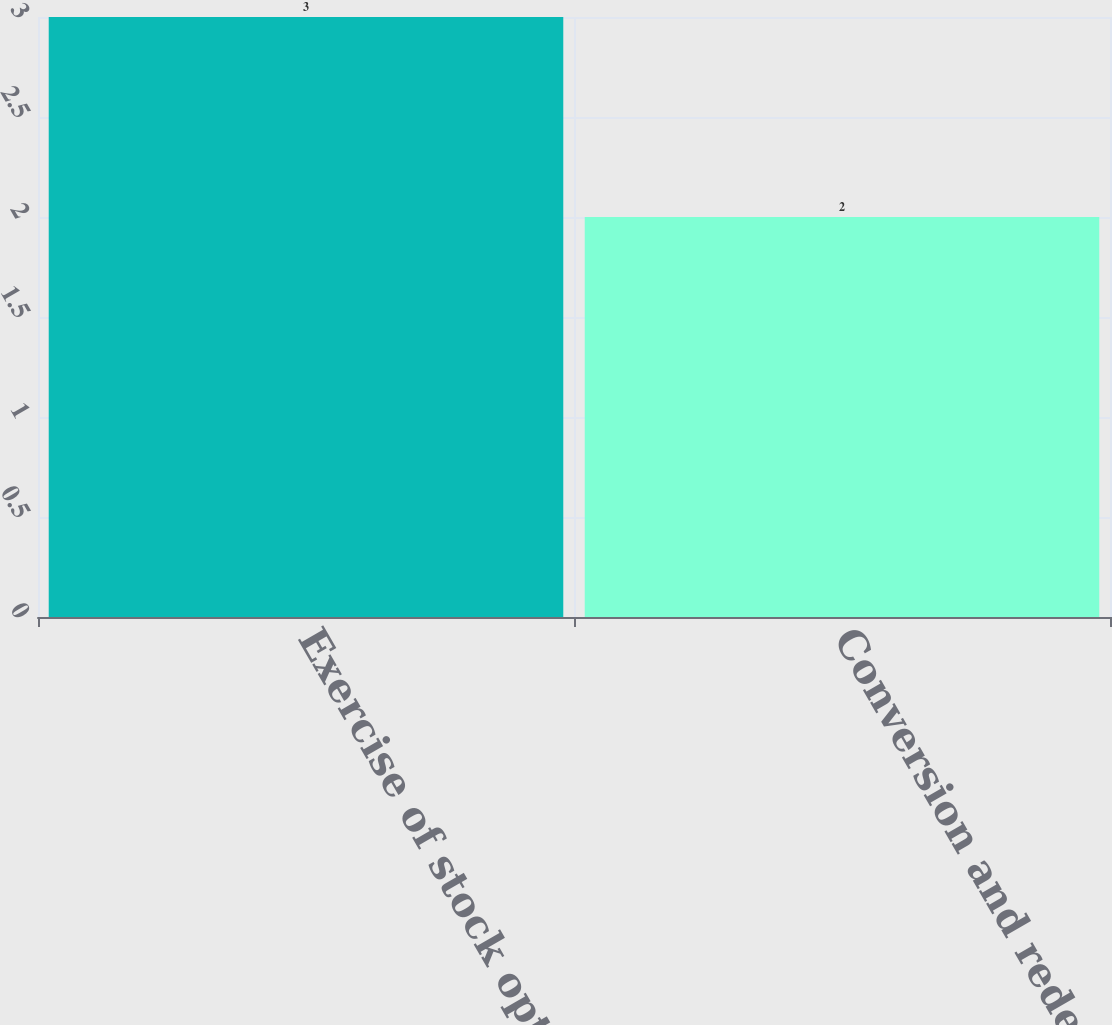Convert chart. <chart><loc_0><loc_0><loc_500><loc_500><bar_chart><fcel>Exercise of stock options<fcel>Conversion and redemption of<nl><fcel>3<fcel>2<nl></chart> 